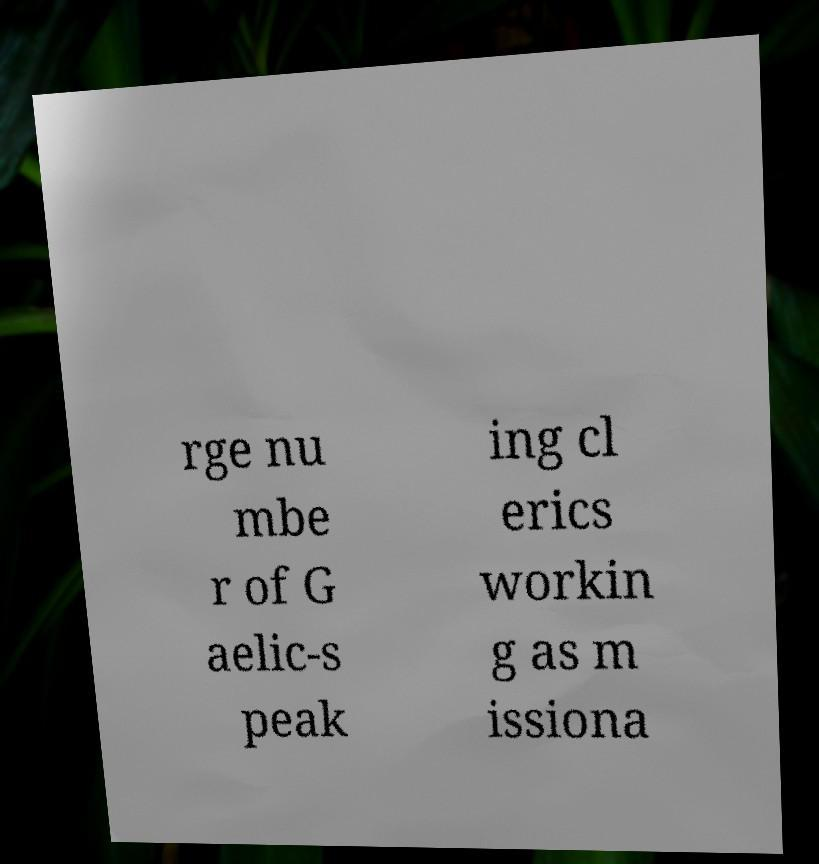Could you extract and type out the text from this image? rge nu mbe r of G aelic-s peak ing cl erics workin g as m issiona 